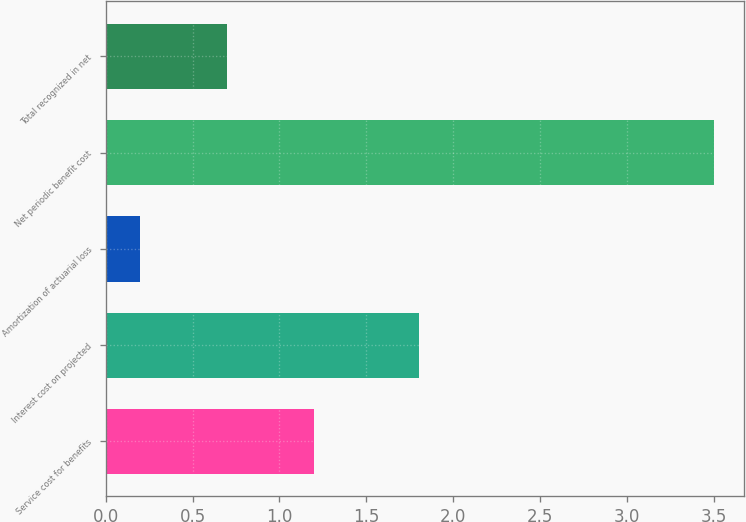Convert chart to OTSL. <chart><loc_0><loc_0><loc_500><loc_500><bar_chart><fcel>Service cost for benefits<fcel>Interest cost on projected<fcel>Amortization of actuarial loss<fcel>Net periodic benefit cost<fcel>Total recognized in net<nl><fcel>1.2<fcel>1.8<fcel>0.2<fcel>3.5<fcel>0.7<nl></chart> 